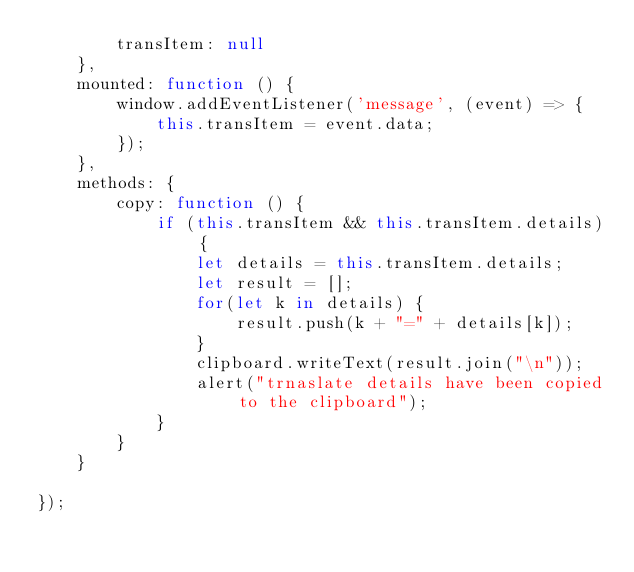<code> <loc_0><loc_0><loc_500><loc_500><_JavaScript_>        transItem: null
    },
    mounted: function () {
        window.addEventListener('message', (event) => {
            this.transItem = event.data;
        });
    },
    methods: {
        copy: function () {
            if (this.transItem && this.transItem.details) {
                let details = this.transItem.details;
                let result = [];
                for(let k in details) {
                    result.push(k + "=" + details[k]);
                }
                clipboard.writeText(result.join("\n"));
                alert("trnaslate details have been copied to the clipboard");
            }
        } 
    }

});

</code> 